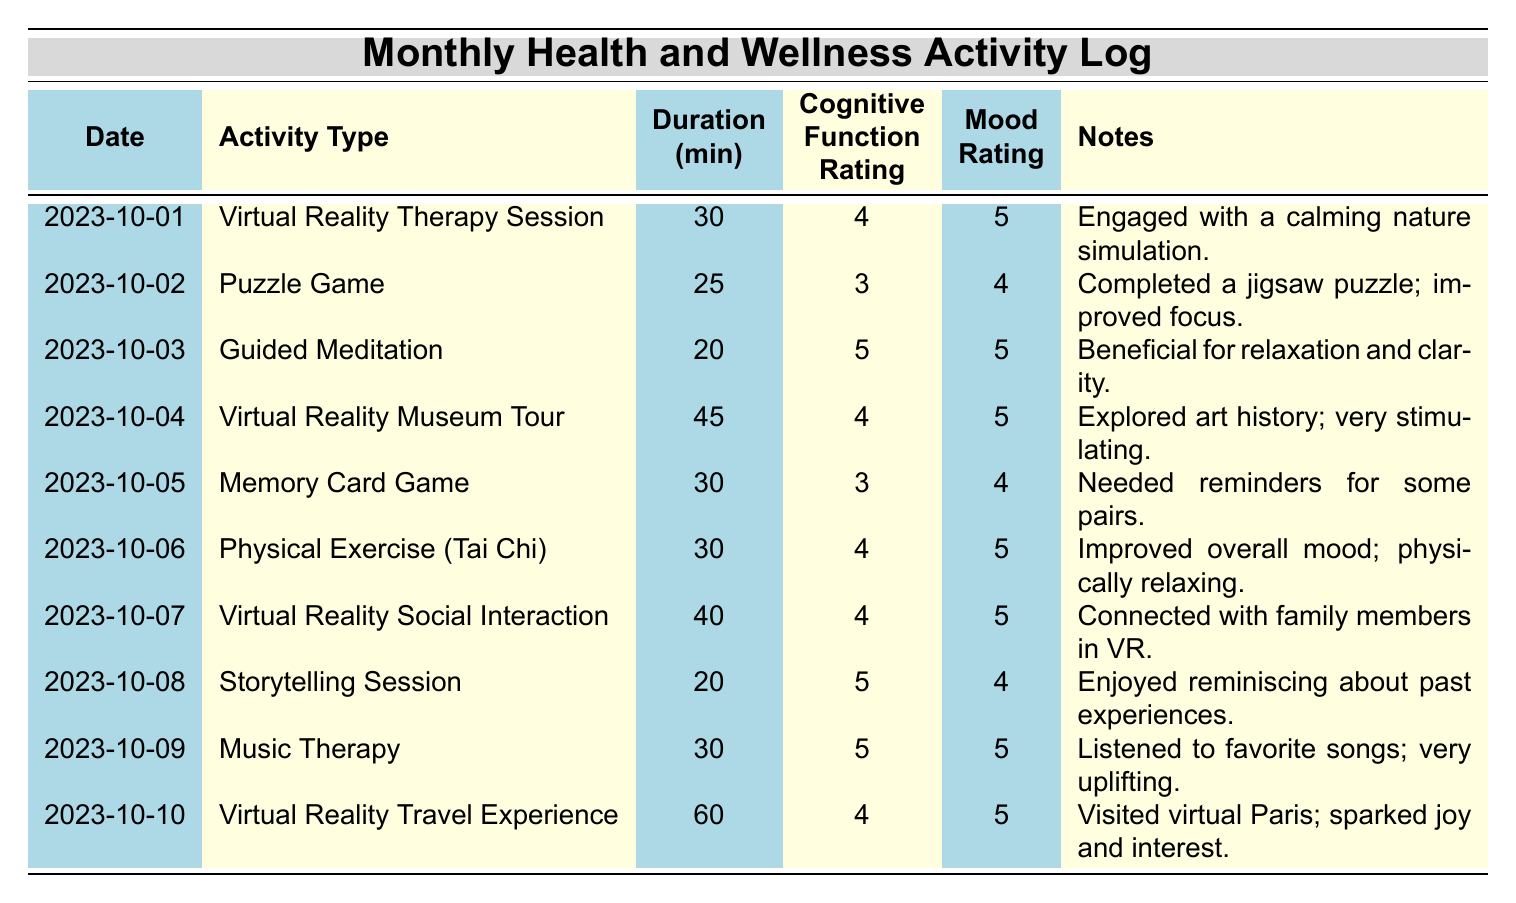What was the mood rating for the Virtual Reality Travel Experience? The Virtual Reality Travel Experience occurred on 2023-10-10, and its mood rating is explicitly provided in the table. It shows a mood rating of 5.
Answer: 5 How many minutes did the Guided Meditation activity last? The Guided Meditation activity is listed in the table under the date 2023-10-03, and it states the duration was 20 minutes.
Answer: 20 What is the average cognitive function rating for the activities listed? To find the average cognitive function rating, first sum all the ratings: (4 + 3 + 5 + 4 + 3 + 4 + 4 + 5 + 5 + 4) = 45. There are 10 activities, so divide 45 by 10, which gives 4.5.
Answer: 4.5 Were any activities rated with a cognitive function rating of 5? A quick scan of the table shows that the activities on 2023-10-03 (Guided Meditation), 2023-10-08 (Storytelling Session), and 2023-10-09 (Music Therapy) have cognitive function ratings of 5, so the statement is true.
Answer: Yes Which activity had the longest duration, and how long was it? The entry for the Virtual Reality Travel Experience on 2023-10-10 has the highest duration listed at 60 minutes. This is confirmed by comparing all durations in the table.
Answer: Virtual Reality Travel Experience, 60 minutes What is the total duration of all the activities combined? The durations are: 30 + 25 + 20 + 45 + 30 + 30 + 40 + 20 + 30 + 60 = 390 minutes. Thus, adding all durations gives a total.
Answer: 390 minutes On which date was the Memory Card Game played and what was its mood rating? The Memory Card Game is listed on 2023-10-05, with a mood rating noted as 4 in the table.
Answer: 2023-10-05, 4 How many activities had mood ratings above 4? The activities with mood ratings above 4 are: Virtual Reality Therapy Session (5), Guided Meditation (5), Virtual Reality Museum Tour (5), Physical Exercise (5), Virtual Reality Social Interaction (5), Music Therapy (5), and Virtual Reality Travel Experience (5). This gives a total of 7.
Answer: 7 Did you engage in any physical exercise activities? The table shows a Physical Exercise (Tai Chi) entry on 2023-10-06, indicating that there was indeed a physical exercise activity conducted.
Answer: Yes What was the lowest cognitive function rating in the activities recorded? The lowest cognitive function ratings are both 3 for the Puzzle Game and the Memory Card Game as listed in the table.
Answer: 3 